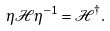Convert formula to latex. <formula><loc_0><loc_0><loc_500><loc_500>\eta \mathcal { H } \eta ^ { - 1 } = \mathcal { H } ^ { \dag } .</formula> 